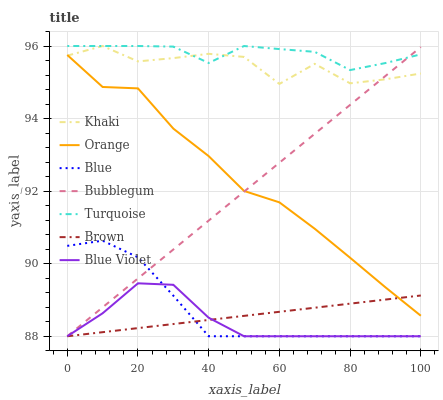Does Blue Violet have the minimum area under the curve?
Answer yes or no. Yes. Does Turquoise have the maximum area under the curve?
Answer yes or no. Yes. Does Brown have the minimum area under the curve?
Answer yes or no. No. Does Brown have the maximum area under the curve?
Answer yes or no. No. Is Brown the smoothest?
Answer yes or no. Yes. Is Khaki the roughest?
Answer yes or no. Yes. Is Turquoise the smoothest?
Answer yes or no. No. Is Turquoise the roughest?
Answer yes or no. No. Does Blue have the lowest value?
Answer yes or no. Yes. Does Turquoise have the lowest value?
Answer yes or no. No. Does Khaki have the highest value?
Answer yes or no. Yes. Does Brown have the highest value?
Answer yes or no. No. Is Blue less than Orange?
Answer yes or no. Yes. Is Turquoise greater than Blue?
Answer yes or no. Yes. Does Blue Violet intersect Brown?
Answer yes or no. Yes. Is Blue Violet less than Brown?
Answer yes or no. No. Is Blue Violet greater than Brown?
Answer yes or no. No. Does Blue intersect Orange?
Answer yes or no. No. 